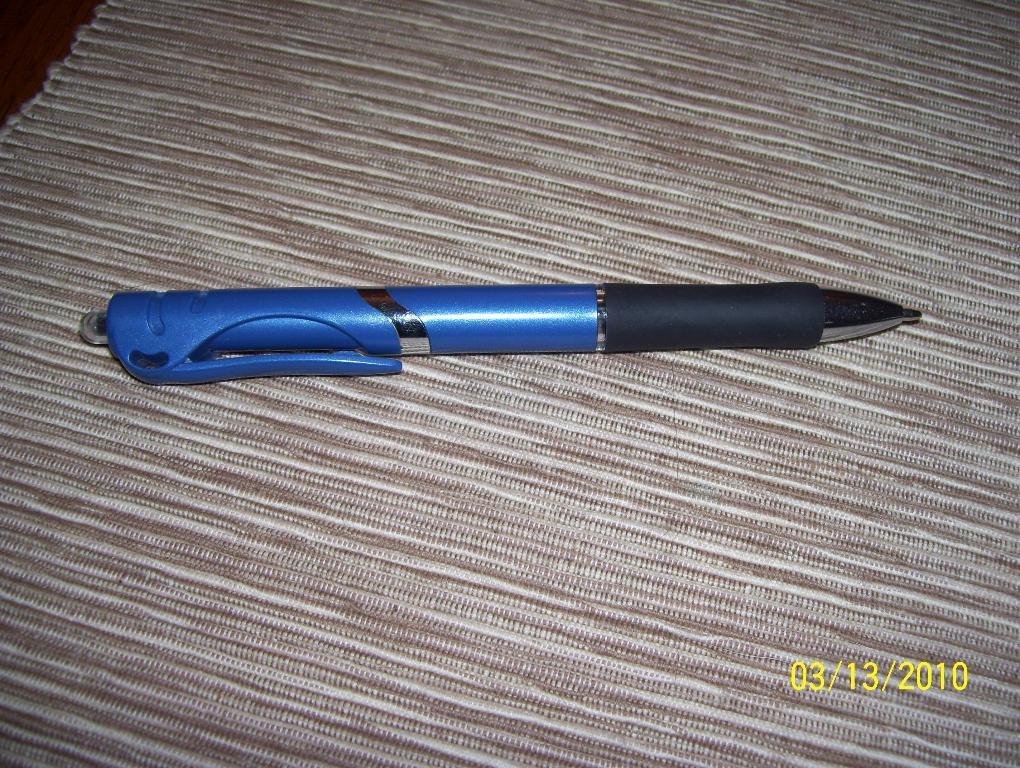In one or two sentences, can you explain what this image depicts? In this image I can see the pen on the brown and cream color cloth. The pen is in blue and black color. 